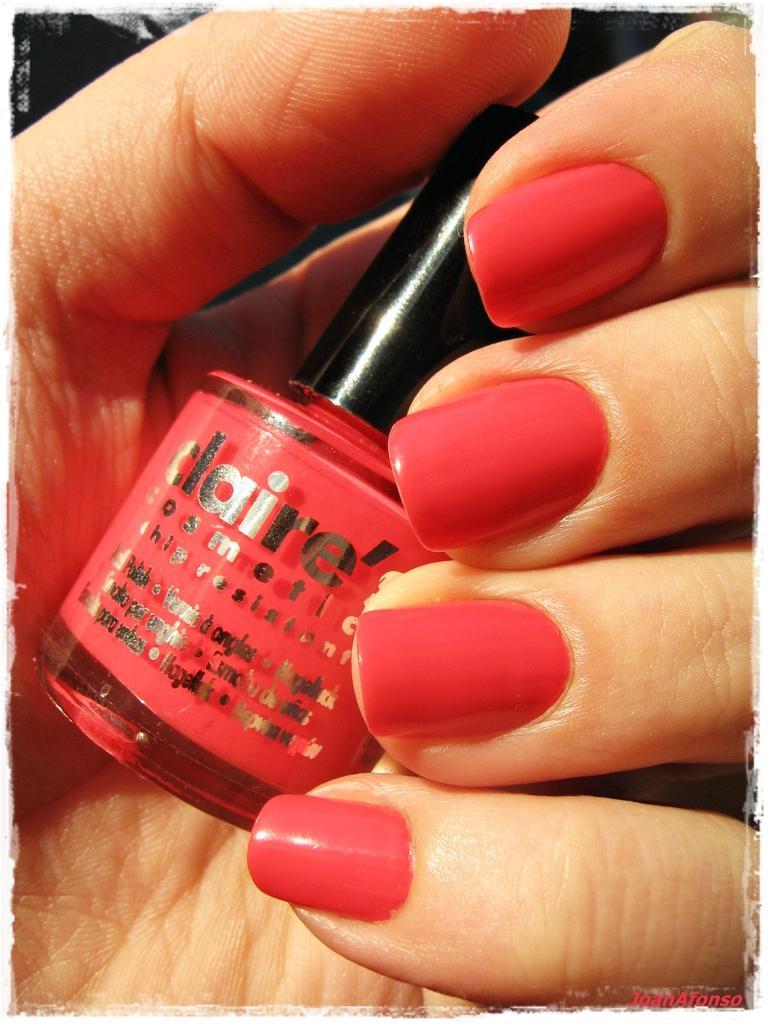Could you give a brief overview of what you see in this image? In this image we can see hand of a person holding a nail polish. 